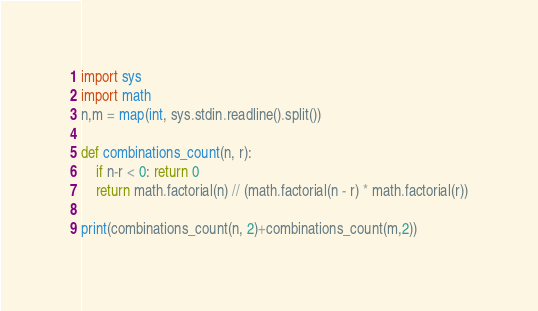<code> <loc_0><loc_0><loc_500><loc_500><_Python_>import sys
import math
n,m = map(int, sys.stdin.readline().split())

def combinations_count(n, r):
    if n-r < 0: return 0
    return math.factorial(n) // (math.factorial(n - r) * math.factorial(r))

print(combinations_count(n, 2)+combinations_count(m,2))
</code> 